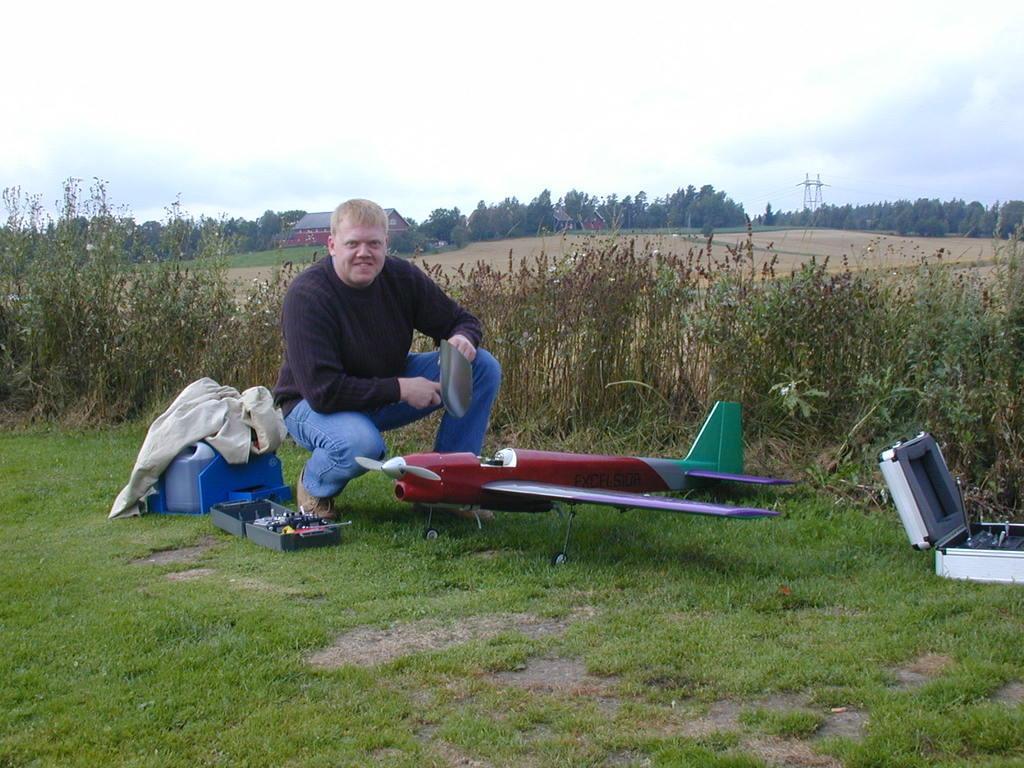Could you give a brief overview of what you see in this image? In this image, we can see a person and the ground with some objects. We can also see some grass and plants. There are a few trees and towers. We can also see a house and the sky with clouds. 